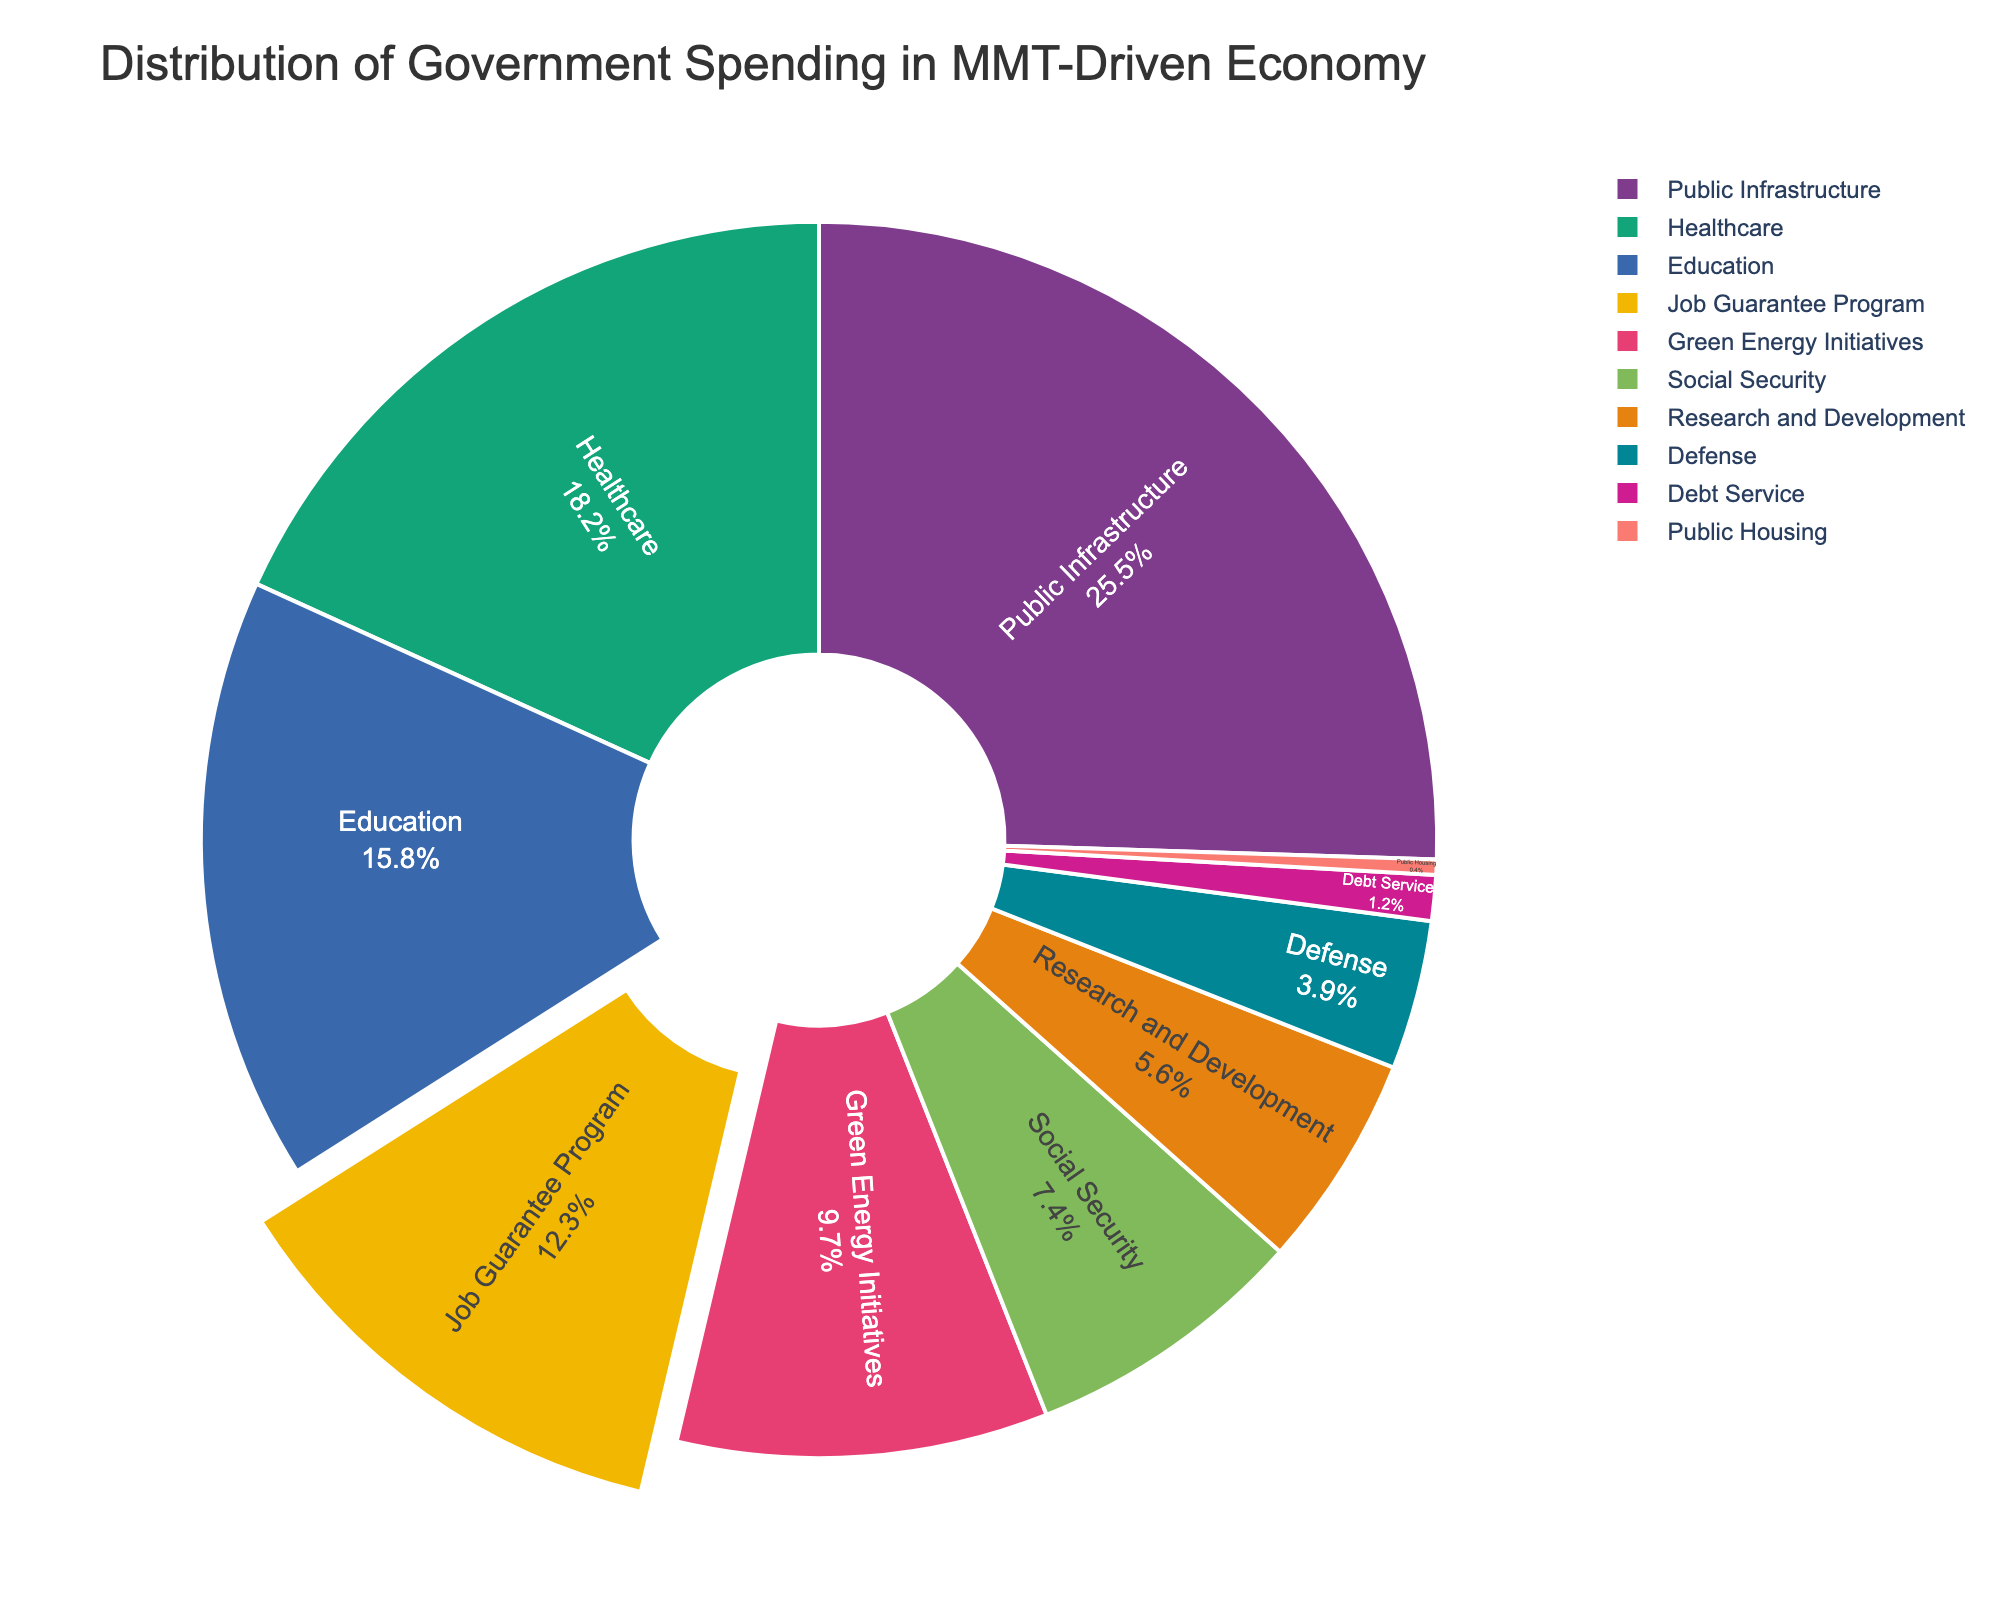Which sector receives the highest percentage of government spending? Identify the sector with the highest value in the pie chart, which is 25.5% for Public Infrastructure.
Answer: Public Infrastructure What is the combined percentage of spending on Healthcare and Education? Add the percentages for Healthcare (18.2%) and Education (15.8%) together: 18.2 + 15.8 = 34%.
Answer: 34% How does the spending on the Job Guarantee Program compare to spending on Green Energy Initiatives? Compare the percentages for the Job Guarantee Program (12.3%) and Green Energy Initiatives (9.7%). The Job Guarantee Program has a higher percentage.
Answer: The Job Guarantee Program receives more funding What is the total percentage of government spending allocated to Social Security, Research and Development, and Defense? Add the percentages for Social Security (7.4%), Research and Development (5.6%), and Defense (3.9%): 7.4 + 5.6 + 3.9 = 16.9%.
Answer: 16.9% Which sector receives less funding, Public Housing or Debt Service? Compare the percentages: Public Housing receives 0.4% and Debt Service receives 1.2%. Public Housing receives less funding.
Answer: Public Housing How much more is spent on Public Infrastructure than on Social Security? Subtract the percentage for Social Security (7.4%) from the percentage for Public Infrastructure (25.5%): 25.5 - 7.4 = 18.1%.
Answer: 18.1% What is the combined spending on sectors with percentages less than 10%? Add the percentages for sectors under 10%: Green Energy Initiatives (9.7%), Social Security (7.4%), Research and Development (5.6%), Defense (3.9%), Debt Service (1.2%), Public Housing (0.4%): 9.7 + 7.4 + 5.6 + 3.9 + 1.2 + 0.4 = 28.2%.
Answer: 28.2% Which sector, highlighted with a larger segment or pulled out segment, represents a key focus of MMT? The pie chart segment for the Job Guarantee Program is highlighted (pulled out), representing a key focus of MMT.
Answer: Job Guarantee Program 